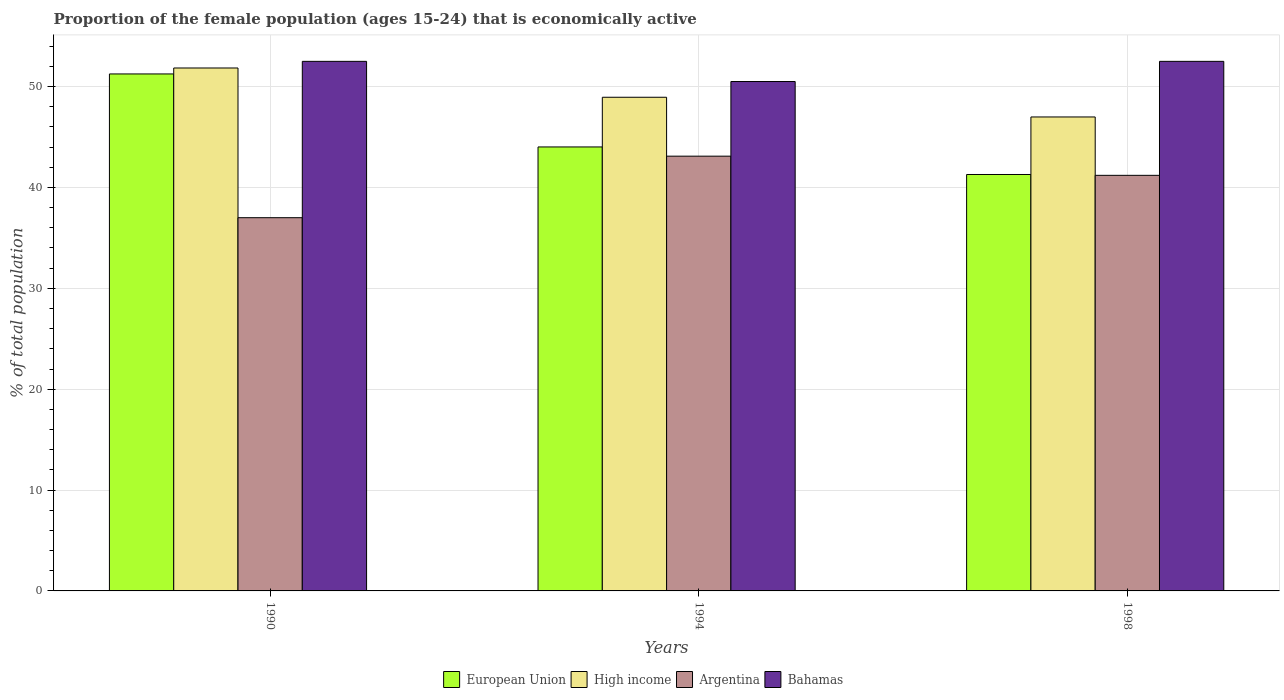How many groups of bars are there?
Give a very brief answer. 3. Are the number of bars per tick equal to the number of legend labels?
Give a very brief answer. Yes. How many bars are there on the 3rd tick from the left?
Ensure brevity in your answer.  4. What is the label of the 2nd group of bars from the left?
Your answer should be very brief. 1994. What is the proportion of the female population that is economically active in Bahamas in 1994?
Provide a succinct answer. 50.5. Across all years, what is the maximum proportion of the female population that is economically active in Bahamas?
Make the answer very short. 52.5. Across all years, what is the minimum proportion of the female population that is economically active in High income?
Your response must be concise. 46.99. What is the total proportion of the female population that is economically active in High income in the graph?
Your answer should be compact. 147.77. What is the difference between the proportion of the female population that is economically active in Bahamas in 1994 and that in 1998?
Make the answer very short. -2. What is the difference between the proportion of the female population that is economically active in Argentina in 1994 and the proportion of the female population that is economically active in Bahamas in 1990?
Your answer should be compact. -9.4. What is the average proportion of the female population that is economically active in Argentina per year?
Keep it short and to the point. 40.43. In the year 1994, what is the difference between the proportion of the female population that is economically active in Bahamas and proportion of the female population that is economically active in High income?
Provide a short and direct response. 1.56. In how many years, is the proportion of the female population that is economically active in European Union greater than 38 %?
Make the answer very short. 3. What is the ratio of the proportion of the female population that is economically active in High income in 1990 to that in 1998?
Your answer should be very brief. 1.1. Is the difference between the proportion of the female population that is economically active in Bahamas in 1994 and 1998 greater than the difference between the proportion of the female population that is economically active in High income in 1994 and 1998?
Give a very brief answer. No. What is the difference between the highest and the second highest proportion of the female population that is economically active in High income?
Provide a succinct answer. 2.9. In how many years, is the proportion of the female population that is economically active in European Union greater than the average proportion of the female population that is economically active in European Union taken over all years?
Offer a very short reply. 1. Is the sum of the proportion of the female population that is economically active in European Union in 1990 and 1998 greater than the maximum proportion of the female population that is economically active in High income across all years?
Provide a short and direct response. Yes. What does the 2nd bar from the right in 1994 represents?
Your answer should be compact. Argentina. How many years are there in the graph?
Offer a terse response. 3. How are the legend labels stacked?
Give a very brief answer. Horizontal. What is the title of the graph?
Your response must be concise. Proportion of the female population (ages 15-24) that is economically active. What is the label or title of the X-axis?
Provide a short and direct response. Years. What is the label or title of the Y-axis?
Give a very brief answer. % of total population. What is the % of total population of European Union in 1990?
Make the answer very short. 51.25. What is the % of total population in High income in 1990?
Offer a terse response. 51.84. What is the % of total population of Argentina in 1990?
Offer a very short reply. 37. What is the % of total population of Bahamas in 1990?
Offer a terse response. 52.5. What is the % of total population of European Union in 1994?
Your answer should be very brief. 44.01. What is the % of total population in High income in 1994?
Offer a very short reply. 48.94. What is the % of total population of Argentina in 1994?
Your answer should be compact. 43.1. What is the % of total population in Bahamas in 1994?
Ensure brevity in your answer.  50.5. What is the % of total population of European Union in 1998?
Your response must be concise. 41.28. What is the % of total population of High income in 1998?
Offer a very short reply. 46.99. What is the % of total population of Argentina in 1998?
Provide a succinct answer. 41.2. What is the % of total population in Bahamas in 1998?
Give a very brief answer. 52.5. Across all years, what is the maximum % of total population of European Union?
Your answer should be very brief. 51.25. Across all years, what is the maximum % of total population of High income?
Provide a short and direct response. 51.84. Across all years, what is the maximum % of total population in Argentina?
Provide a short and direct response. 43.1. Across all years, what is the maximum % of total population of Bahamas?
Keep it short and to the point. 52.5. Across all years, what is the minimum % of total population in European Union?
Make the answer very short. 41.28. Across all years, what is the minimum % of total population in High income?
Your answer should be very brief. 46.99. Across all years, what is the minimum % of total population in Argentina?
Give a very brief answer. 37. Across all years, what is the minimum % of total population of Bahamas?
Your answer should be compact. 50.5. What is the total % of total population in European Union in the graph?
Your answer should be very brief. 136.55. What is the total % of total population of High income in the graph?
Keep it short and to the point. 147.77. What is the total % of total population of Argentina in the graph?
Give a very brief answer. 121.3. What is the total % of total population of Bahamas in the graph?
Provide a succinct answer. 155.5. What is the difference between the % of total population in European Union in 1990 and that in 1994?
Make the answer very short. 7.24. What is the difference between the % of total population in High income in 1990 and that in 1994?
Offer a terse response. 2.9. What is the difference between the % of total population of Argentina in 1990 and that in 1994?
Give a very brief answer. -6.1. What is the difference between the % of total population of Bahamas in 1990 and that in 1994?
Offer a very short reply. 2. What is the difference between the % of total population of European Union in 1990 and that in 1998?
Make the answer very short. 9.97. What is the difference between the % of total population in High income in 1990 and that in 1998?
Your answer should be very brief. 4.85. What is the difference between the % of total population in Argentina in 1990 and that in 1998?
Offer a very short reply. -4.2. What is the difference between the % of total population in Bahamas in 1990 and that in 1998?
Your answer should be compact. 0. What is the difference between the % of total population in European Union in 1994 and that in 1998?
Keep it short and to the point. 2.73. What is the difference between the % of total population of High income in 1994 and that in 1998?
Make the answer very short. 1.95. What is the difference between the % of total population in Bahamas in 1994 and that in 1998?
Your answer should be compact. -2. What is the difference between the % of total population in European Union in 1990 and the % of total population in High income in 1994?
Your answer should be very brief. 2.31. What is the difference between the % of total population of European Union in 1990 and the % of total population of Argentina in 1994?
Keep it short and to the point. 8.15. What is the difference between the % of total population of European Union in 1990 and the % of total population of Bahamas in 1994?
Give a very brief answer. 0.75. What is the difference between the % of total population in High income in 1990 and the % of total population in Argentina in 1994?
Provide a succinct answer. 8.74. What is the difference between the % of total population in High income in 1990 and the % of total population in Bahamas in 1994?
Your answer should be compact. 1.34. What is the difference between the % of total population in European Union in 1990 and the % of total population in High income in 1998?
Keep it short and to the point. 4.26. What is the difference between the % of total population of European Union in 1990 and the % of total population of Argentina in 1998?
Ensure brevity in your answer.  10.05. What is the difference between the % of total population of European Union in 1990 and the % of total population of Bahamas in 1998?
Provide a short and direct response. -1.25. What is the difference between the % of total population of High income in 1990 and the % of total population of Argentina in 1998?
Offer a very short reply. 10.64. What is the difference between the % of total population of High income in 1990 and the % of total population of Bahamas in 1998?
Ensure brevity in your answer.  -0.66. What is the difference between the % of total population in Argentina in 1990 and the % of total population in Bahamas in 1998?
Provide a short and direct response. -15.5. What is the difference between the % of total population in European Union in 1994 and the % of total population in High income in 1998?
Offer a terse response. -2.97. What is the difference between the % of total population of European Union in 1994 and the % of total population of Argentina in 1998?
Your answer should be compact. 2.81. What is the difference between the % of total population in European Union in 1994 and the % of total population in Bahamas in 1998?
Your answer should be very brief. -8.49. What is the difference between the % of total population in High income in 1994 and the % of total population in Argentina in 1998?
Give a very brief answer. 7.74. What is the difference between the % of total population in High income in 1994 and the % of total population in Bahamas in 1998?
Your answer should be very brief. -3.56. What is the difference between the % of total population in Argentina in 1994 and the % of total population in Bahamas in 1998?
Give a very brief answer. -9.4. What is the average % of total population in European Union per year?
Your answer should be compact. 45.52. What is the average % of total population in High income per year?
Make the answer very short. 49.26. What is the average % of total population in Argentina per year?
Offer a very short reply. 40.43. What is the average % of total population of Bahamas per year?
Offer a terse response. 51.83. In the year 1990, what is the difference between the % of total population in European Union and % of total population in High income?
Ensure brevity in your answer.  -0.59. In the year 1990, what is the difference between the % of total population in European Union and % of total population in Argentina?
Offer a very short reply. 14.25. In the year 1990, what is the difference between the % of total population of European Union and % of total population of Bahamas?
Offer a terse response. -1.25. In the year 1990, what is the difference between the % of total population of High income and % of total population of Argentina?
Your answer should be very brief. 14.84. In the year 1990, what is the difference between the % of total population in High income and % of total population in Bahamas?
Your response must be concise. -0.66. In the year 1990, what is the difference between the % of total population of Argentina and % of total population of Bahamas?
Offer a terse response. -15.5. In the year 1994, what is the difference between the % of total population of European Union and % of total population of High income?
Your answer should be very brief. -4.93. In the year 1994, what is the difference between the % of total population of European Union and % of total population of Argentina?
Offer a terse response. 0.91. In the year 1994, what is the difference between the % of total population of European Union and % of total population of Bahamas?
Provide a succinct answer. -6.49. In the year 1994, what is the difference between the % of total population in High income and % of total population in Argentina?
Provide a succinct answer. 5.84. In the year 1994, what is the difference between the % of total population of High income and % of total population of Bahamas?
Give a very brief answer. -1.56. In the year 1994, what is the difference between the % of total population in Argentina and % of total population in Bahamas?
Make the answer very short. -7.4. In the year 1998, what is the difference between the % of total population of European Union and % of total population of High income?
Provide a succinct answer. -5.7. In the year 1998, what is the difference between the % of total population of European Union and % of total population of Argentina?
Your answer should be very brief. 0.08. In the year 1998, what is the difference between the % of total population of European Union and % of total population of Bahamas?
Offer a terse response. -11.22. In the year 1998, what is the difference between the % of total population of High income and % of total population of Argentina?
Your response must be concise. 5.79. In the year 1998, what is the difference between the % of total population of High income and % of total population of Bahamas?
Offer a very short reply. -5.51. What is the ratio of the % of total population in European Union in 1990 to that in 1994?
Make the answer very short. 1.16. What is the ratio of the % of total population in High income in 1990 to that in 1994?
Ensure brevity in your answer.  1.06. What is the ratio of the % of total population in Argentina in 1990 to that in 1994?
Make the answer very short. 0.86. What is the ratio of the % of total population of Bahamas in 1990 to that in 1994?
Give a very brief answer. 1.04. What is the ratio of the % of total population of European Union in 1990 to that in 1998?
Ensure brevity in your answer.  1.24. What is the ratio of the % of total population in High income in 1990 to that in 1998?
Your answer should be very brief. 1.1. What is the ratio of the % of total population of Argentina in 1990 to that in 1998?
Your response must be concise. 0.9. What is the ratio of the % of total population in European Union in 1994 to that in 1998?
Keep it short and to the point. 1.07. What is the ratio of the % of total population in High income in 1994 to that in 1998?
Your answer should be very brief. 1.04. What is the ratio of the % of total population in Argentina in 1994 to that in 1998?
Provide a succinct answer. 1.05. What is the ratio of the % of total population of Bahamas in 1994 to that in 1998?
Ensure brevity in your answer.  0.96. What is the difference between the highest and the second highest % of total population of European Union?
Offer a very short reply. 7.24. What is the difference between the highest and the second highest % of total population of High income?
Give a very brief answer. 2.9. What is the difference between the highest and the second highest % of total population in Bahamas?
Offer a terse response. 0. What is the difference between the highest and the lowest % of total population of European Union?
Offer a very short reply. 9.97. What is the difference between the highest and the lowest % of total population in High income?
Make the answer very short. 4.85. What is the difference between the highest and the lowest % of total population of Argentina?
Your response must be concise. 6.1. 